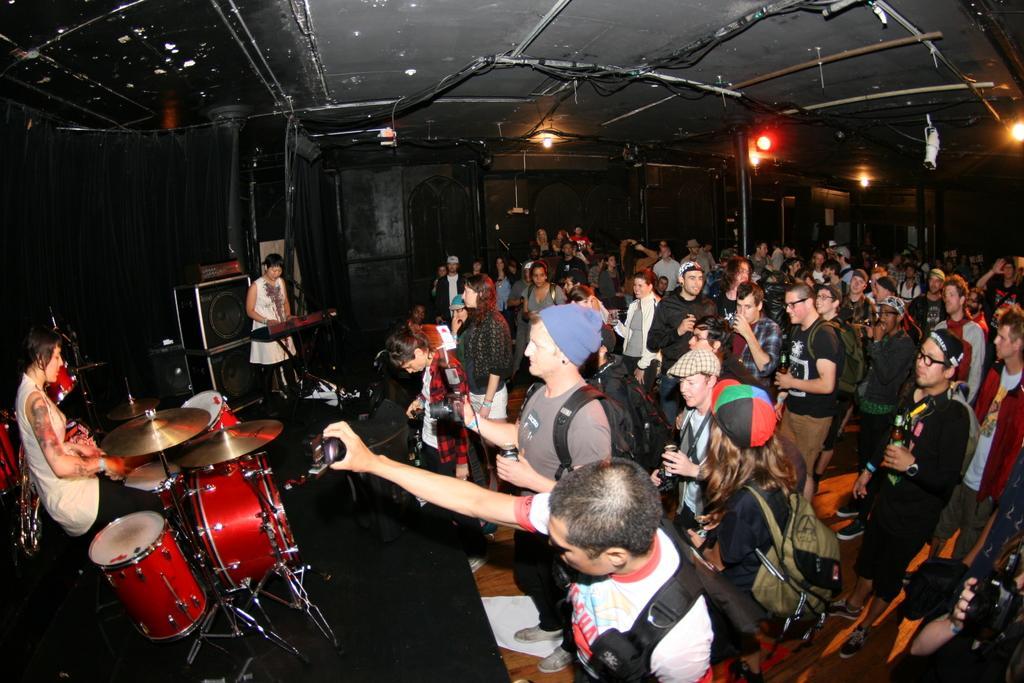Describe this image in one or two sentences. In this image I can see the group of people with different color dresses. I can see few people are wearing the caps and bags. In-front of these people I can see two people playing the musical instruments. To the side of these people I can see the sound boxes. And there is a black background. I can see the lights at the top. 